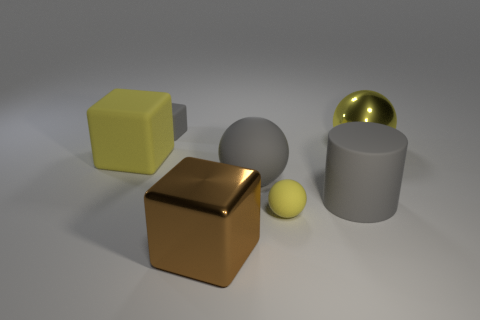Subtract all big cubes. How many cubes are left? 1 Subtract all yellow blocks. How many blocks are left? 2 Subtract 3 balls. How many balls are left? 0 Subtract all purple balls. How many yellow cubes are left? 1 Subtract 1 yellow cubes. How many objects are left? 6 Subtract all blocks. How many objects are left? 4 Subtract all purple blocks. Subtract all blue cylinders. How many blocks are left? 3 Subtract all big yellow metal things. Subtract all small balls. How many objects are left? 5 Add 4 big gray rubber cylinders. How many big gray rubber cylinders are left? 5 Add 5 large yellow rubber cubes. How many large yellow rubber cubes exist? 6 